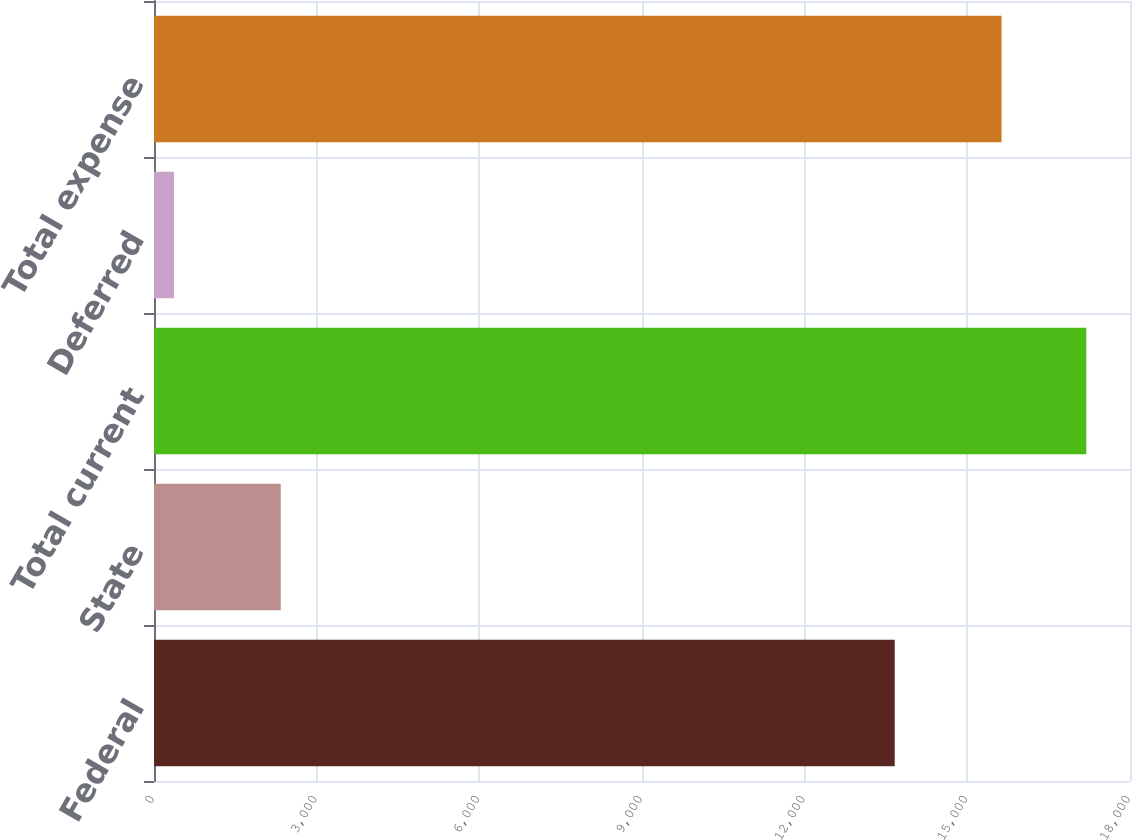Convert chart to OTSL. <chart><loc_0><loc_0><loc_500><loc_500><bar_chart><fcel>Federal<fcel>State<fcel>Total current<fcel>Deferred<fcel>Total expense<nl><fcel>13661<fcel>2338<fcel>17194.1<fcel>368<fcel>15631<nl></chart> 